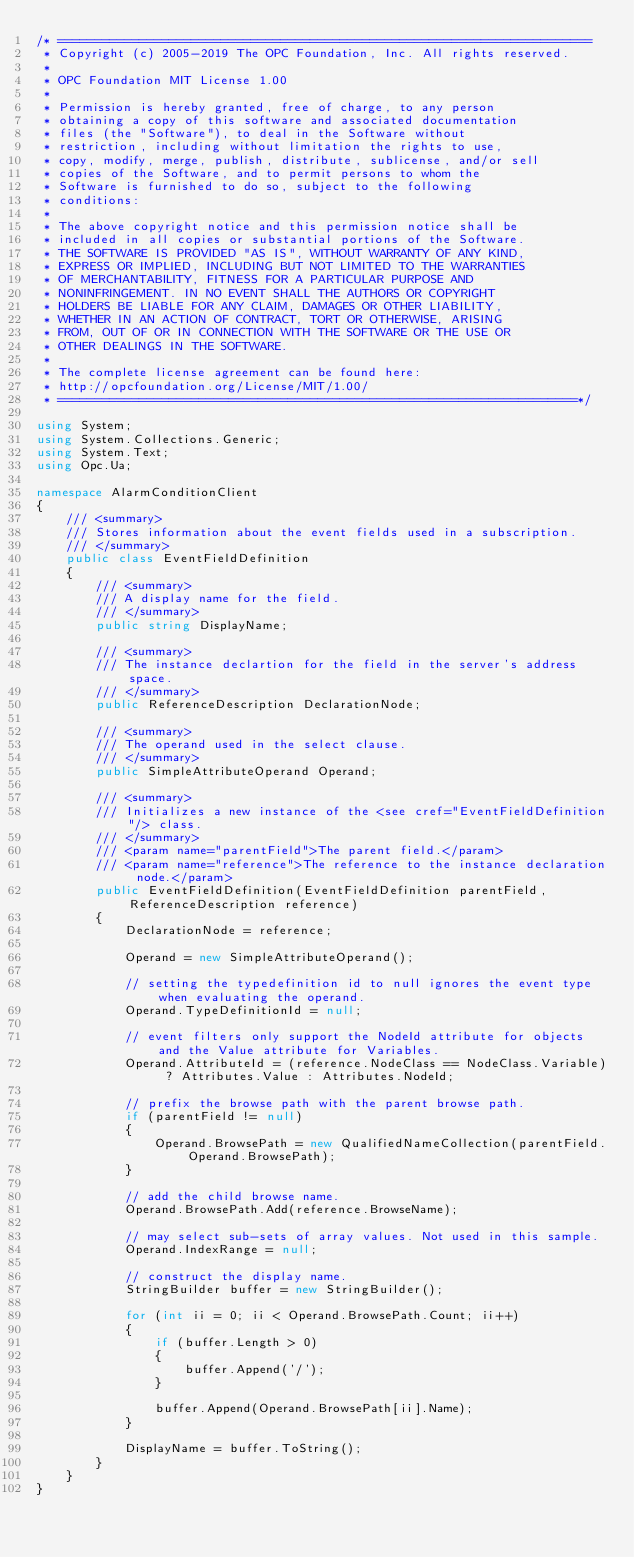Convert code to text. <code><loc_0><loc_0><loc_500><loc_500><_C#_>/* ========================================================================
 * Copyright (c) 2005-2019 The OPC Foundation, Inc. All rights reserved.
 *
 * OPC Foundation MIT License 1.00
 * 
 * Permission is hereby granted, free of charge, to any person
 * obtaining a copy of this software and associated documentation
 * files (the "Software"), to deal in the Software without
 * restriction, including without limitation the rights to use,
 * copy, modify, merge, publish, distribute, sublicense, and/or sell
 * copies of the Software, and to permit persons to whom the
 * Software is furnished to do so, subject to the following
 * conditions:
 * 
 * The above copyright notice and this permission notice shall be
 * included in all copies or substantial portions of the Software.
 * THE SOFTWARE IS PROVIDED "AS IS", WITHOUT WARRANTY OF ANY KIND,
 * EXPRESS OR IMPLIED, INCLUDING BUT NOT LIMITED TO THE WARRANTIES
 * OF MERCHANTABILITY, FITNESS FOR A PARTICULAR PURPOSE AND
 * NONINFRINGEMENT. IN NO EVENT SHALL THE AUTHORS OR COPYRIGHT
 * HOLDERS BE LIABLE FOR ANY CLAIM, DAMAGES OR OTHER LIABILITY,
 * WHETHER IN AN ACTION OF CONTRACT, TORT OR OTHERWISE, ARISING
 * FROM, OUT OF OR IN CONNECTION WITH THE SOFTWARE OR THE USE OR
 * OTHER DEALINGS IN THE SOFTWARE.
 *
 * The complete license agreement can be found here:
 * http://opcfoundation.org/License/MIT/1.00/
 * ======================================================================*/

using System;
using System.Collections.Generic;
using System.Text;
using Opc.Ua;

namespace AlarmConditionClient
{
    /// <summary>
    /// Stores information about the event fields used in a subscription.
    /// </summary>
    public class EventFieldDefinition
    {
        /// <summary>
        /// A display name for the field.
        /// </summary>
        public string DisplayName;

        /// <summary>
        /// The instance declartion for the field in the server's address space.
        /// </summary>
        public ReferenceDescription DeclarationNode;

        /// <summary>
        /// The operand used in the select clause.
        /// </summary>
        public SimpleAttributeOperand Operand;

        /// <summary>
        /// Initializes a new instance of the <see cref="EventFieldDefinition"/> class.
        /// </summary>
        /// <param name="parentField">The parent field.</param>
        /// <param name="reference">The reference to the instance declaration node.</param>
        public EventFieldDefinition(EventFieldDefinition parentField, ReferenceDescription reference)
        {
            DeclarationNode = reference;

            Operand = new SimpleAttributeOperand();

            // setting the typedefinition id to null ignores the event type when evaluating the operand.
            Operand.TypeDefinitionId = null;

            // event filters only support the NodeId attribute for objects and the Value attribute for Variables.
            Operand.AttributeId = (reference.NodeClass == NodeClass.Variable) ? Attributes.Value : Attributes.NodeId;

            // prefix the browse path with the parent browse path.
            if (parentField != null)
            {
                Operand.BrowsePath = new QualifiedNameCollection(parentField.Operand.BrowsePath);
            }

            // add the child browse name.
            Operand.BrowsePath.Add(reference.BrowseName);

            // may select sub-sets of array values. Not used in this sample.
            Operand.IndexRange = null;

            // construct the display name.
            StringBuilder buffer = new StringBuilder();

            for (int ii = 0; ii < Operand.BrowsePath.Count; ii++)
            {
                if (buffer.Length > 0)
                {
                    buffer.Append('/');
                }

                buffer.Append(Operand.BrowsePath[ii].Name);
            }

            DisplayName = buffer.ToString();
        }
    }
}
</code> 